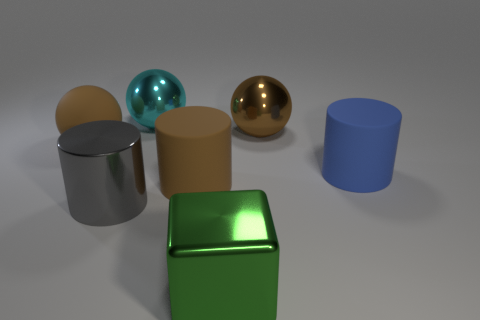What number of other objects are there of the same color as the matte ball?
Your response must be concise. 2. There is a rubber thing that is the same color as the big matte sphere; what shape is it?
Offer a terse response. Cylinder. What number of green objects are spheres or big metallic blocks?
Offer a very short reply. 1. There is a brown thing left of the large cyan sphere; is its shape the same as the blue object?
Provide a succinct answer. No. Is the number of things on the right side of the gray cylinder greater than the number of big metal things?
Your response must be concise. Yes. What number of metal cylinders are the same size as the matte ball?
Your answer should be very brief. 1. What number of things are large brown metallic cylinders or objects behind the blue object?
Provide a succinct answer. 3. There is a big ball that is both in front of the large cyan metal ball and right of the big rubber sphere; what color is it?
Offer a very short reply. Brown. What color is the big matte object that is on the left side of the brown rubber cylinder?
Keep it short and to the point. Brown. Are there any large objects of the same color as the large matte sphere?
Your response must be concise. Yes. 